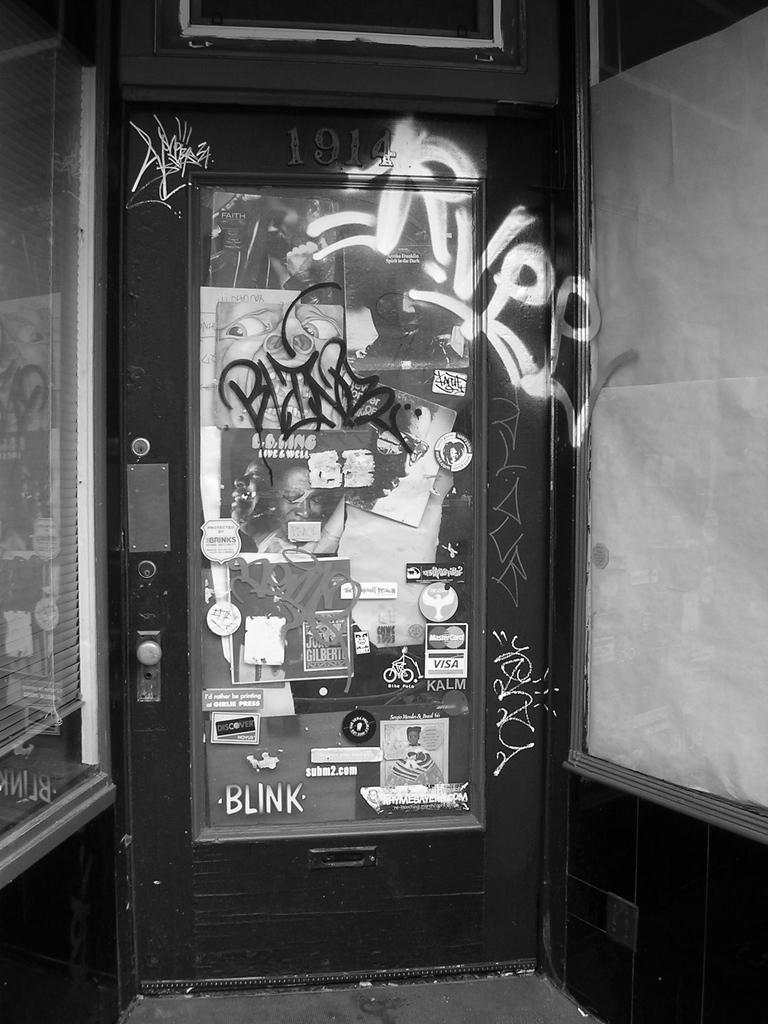What type of structure can be seen in the image? There is a door in the image. What decorative elements are present in the image? There are posters in the image. What type of walls are visible in the image? There are glass walls in the image. What type of window covering is present in the image? There is a window blind in the image. Can you tell me what type of band is performing in the image? There is no band present in the image; it only features a door, posters, glass walls, and a window blind. What type of zebra can be seen in the image? There is no zebra present in the image. 